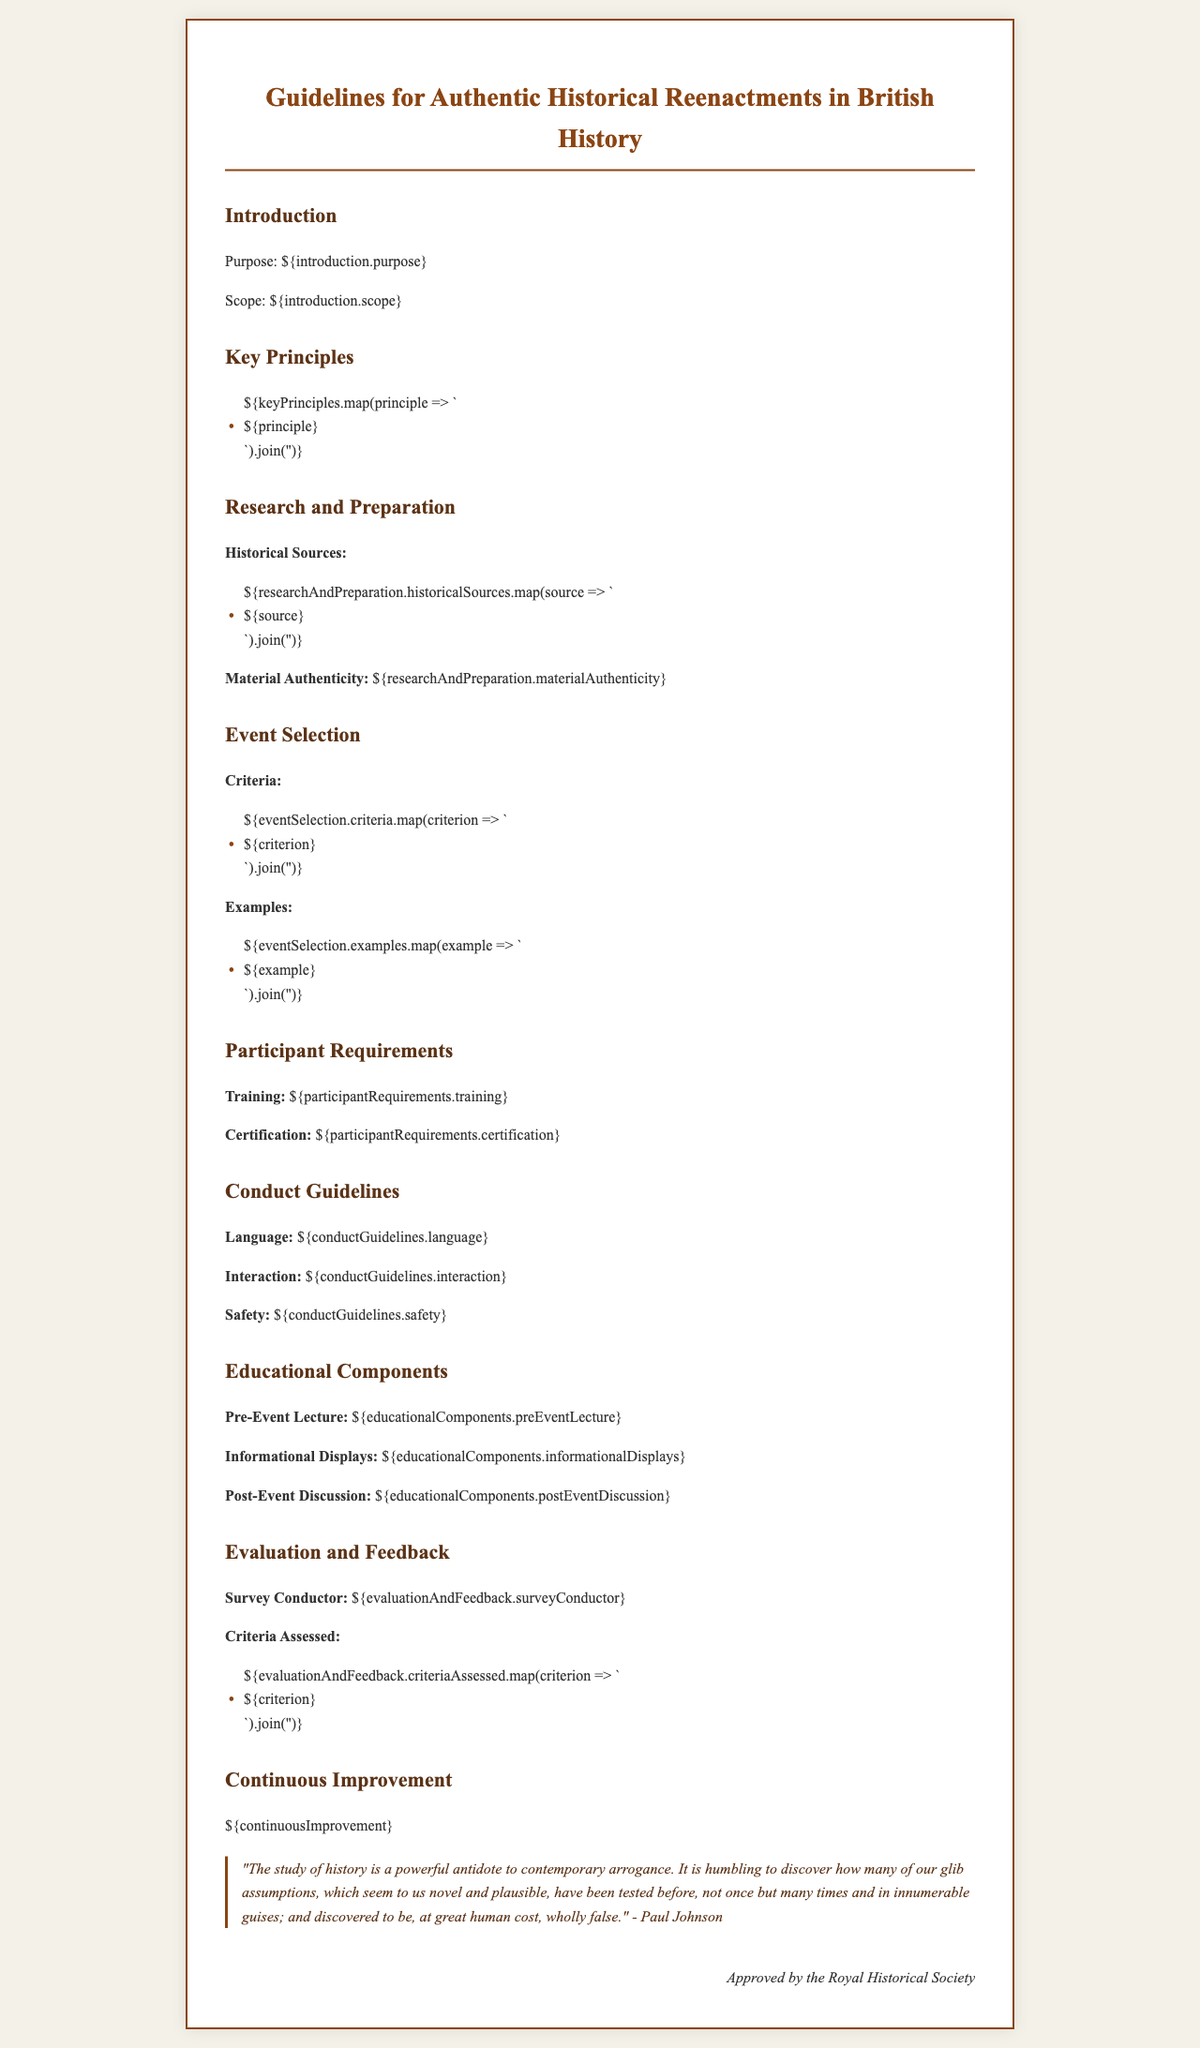What is the purpose of the guidelines? The purpose is defined in the introduction section of the document, outlining the goals of the historical reenactments.
Answer: Authenticity and educational value What are the key principles of historical reenactments? The key principles are listed under the "Key Principles" section, highlighting fundamental values to uphold during reenactments.
Answer: Various principles What types of historical sources should be used for research? The specific historical sources are enumerated in the "Research and Preparation" section, detailing types of references to be utilized.
Answer: Various sources What is required for participant certification? Certification requirements are stated under the "Participant Requirements" section to ensure qualified individuals participate in reenactments.
Answer: Certification Who approves the guidelines? The approving body is mentioned at the end of the document, signaling official endorsement of the guidelines.
Answer: Royal Historical Society What is one of the educational components mentioned? Educational components are outlined under their specific section, including activities designed to enhance learning during events.
Answer: Pre-Event Lecture What criteria are used for event selection? The criteria for event selection are specified in the "Event Selection" section, outlining standards for choosing which events to reenact.
Answer: Various criteria What is emphasized in conducting interactions during reenactments? Conduct guidelines specifically highlight important aspects of interaction that participants must adhere to during reenactments.
Answer: Respect How often should feedback be gathered? The document implies a regularity for evaluation and feedback, specifying ongoing improvement practices based on participant input.
Answer: Continuous Improvement What is the significance of the quote at the end of the document? The quote underscores the importance of historical perspective, emphasizing lessons learned from history relevant to modern society.
Answer: Humbling insights from history 